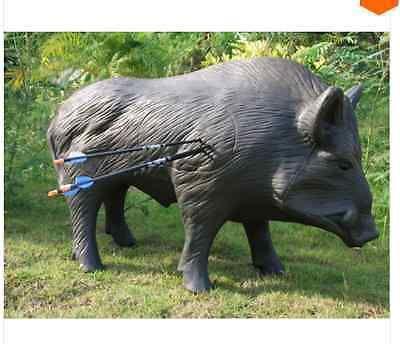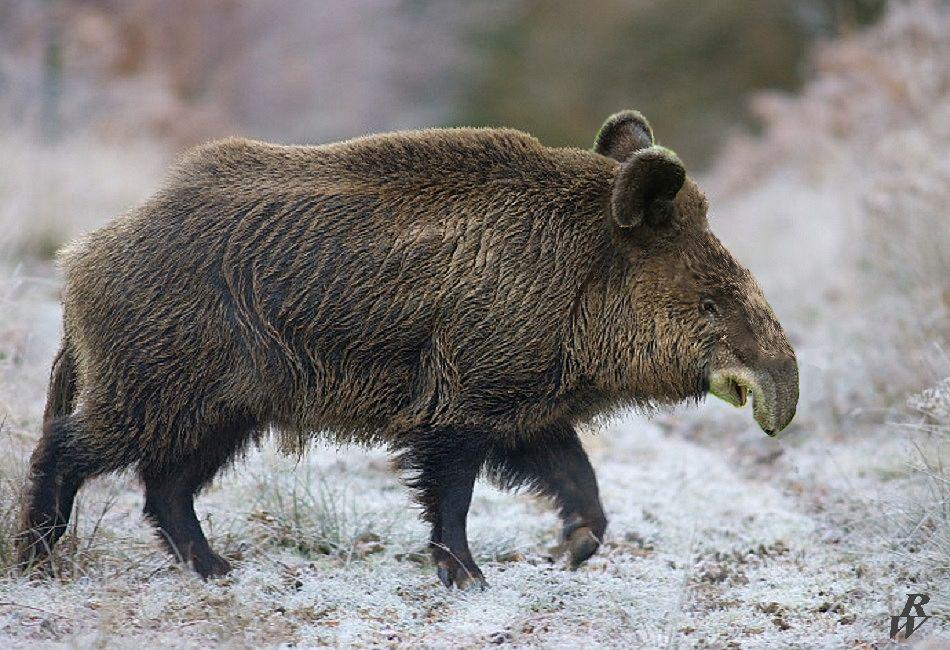The first image is the image on the left, the second image is the image on the right. Analyze the images presented: Is the assertion "One of the wild pigs is standing in profile, and the other pig is standing with its snout aimed forward." valid? Answer yes or no. No. The first image is the image on the left, the second image is the image on the right. Given the left and right images, does the statement "A pig is walking in the snow." hold true? Answer yes or no. Yes. 